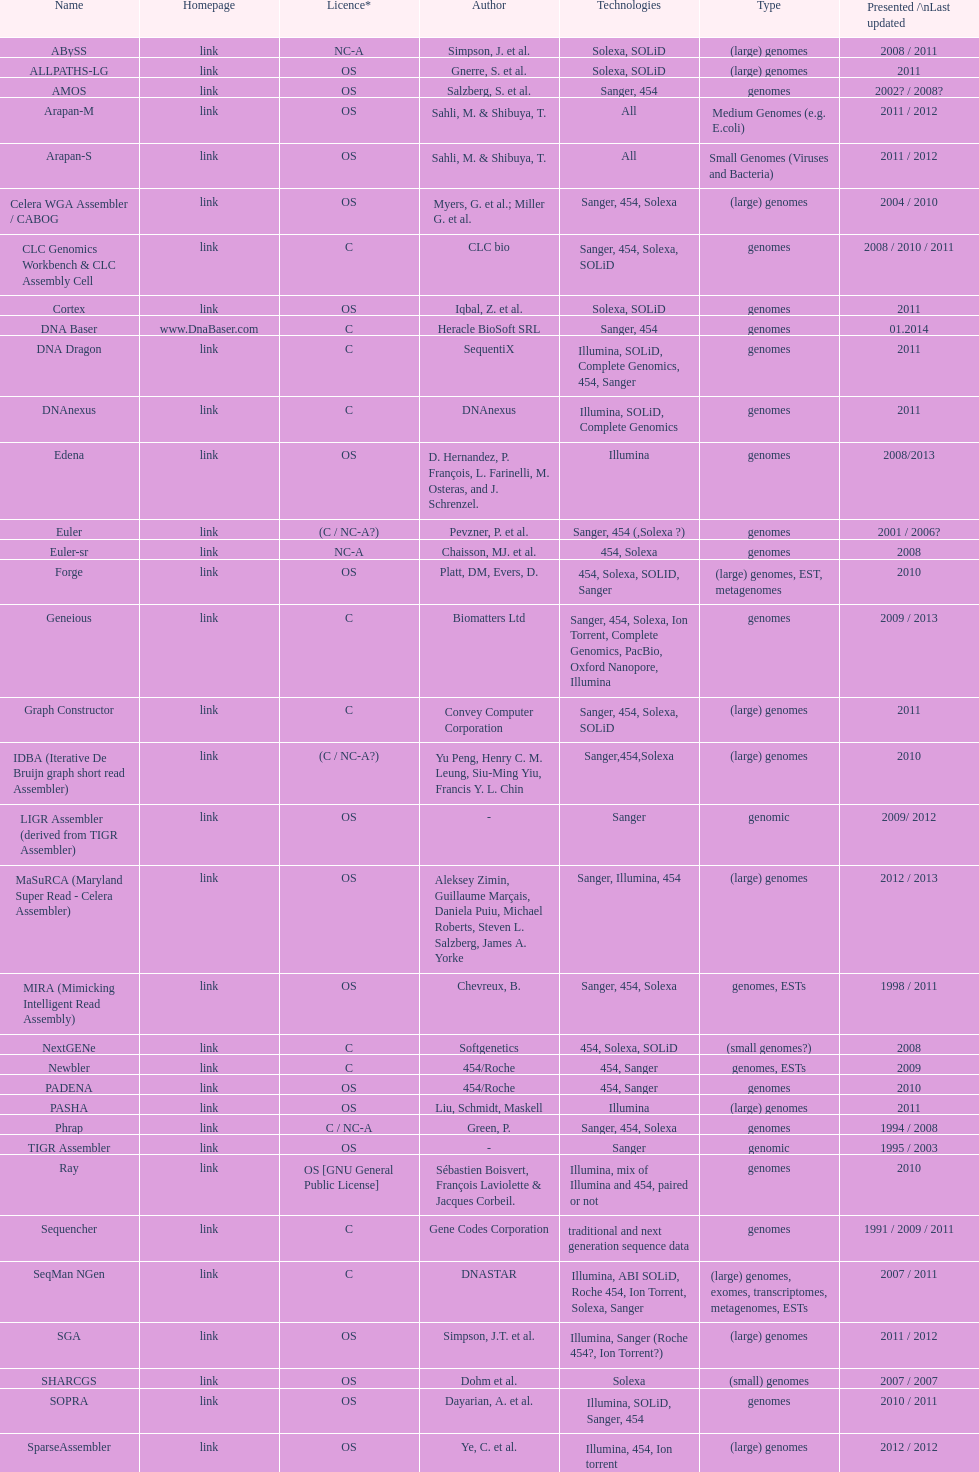How many assemblers are compatible with medium genome type technologies? 1. 